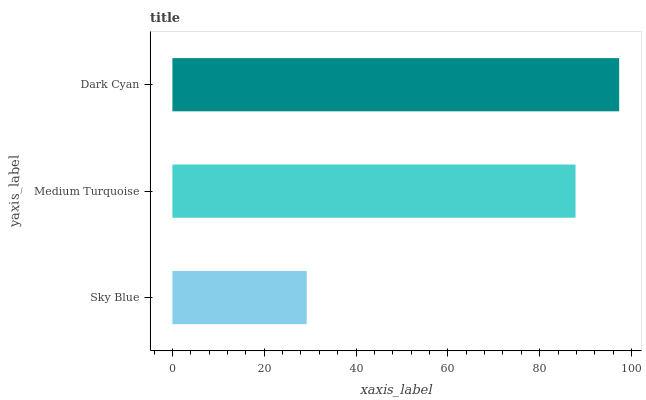Is Sky Blue the minimum?
Answer yes or no. Yes. Is Dark Cyan the maximum?
Answer yes or no. Yes. Is Medium Turquoise the minimum?
Answer yes or no. No. Is Medium Turquoise the maximum?
Answer yes or no. No. Is Medium Turquoise greater than Sky Blue?
Answer yes or no. Yes. Is Sky Blue less than Medium Turquoise?
Answer yes or no. Yes. Is Sky Blue greater than Medium Turquoise?
Answer yes or no. No. Is Medium Turquoise less than Sky Blue?
Answer yes or no. No. Is Medium Turquoise the high median?
Answer yes or no. Yes. Is Medium Turquoise the low median?
Answer yes or no. Yes. Is Sky Blue the high median?
Answer yes or no. No. Is Sky Blue the low median?
Answer yes or no. No. 